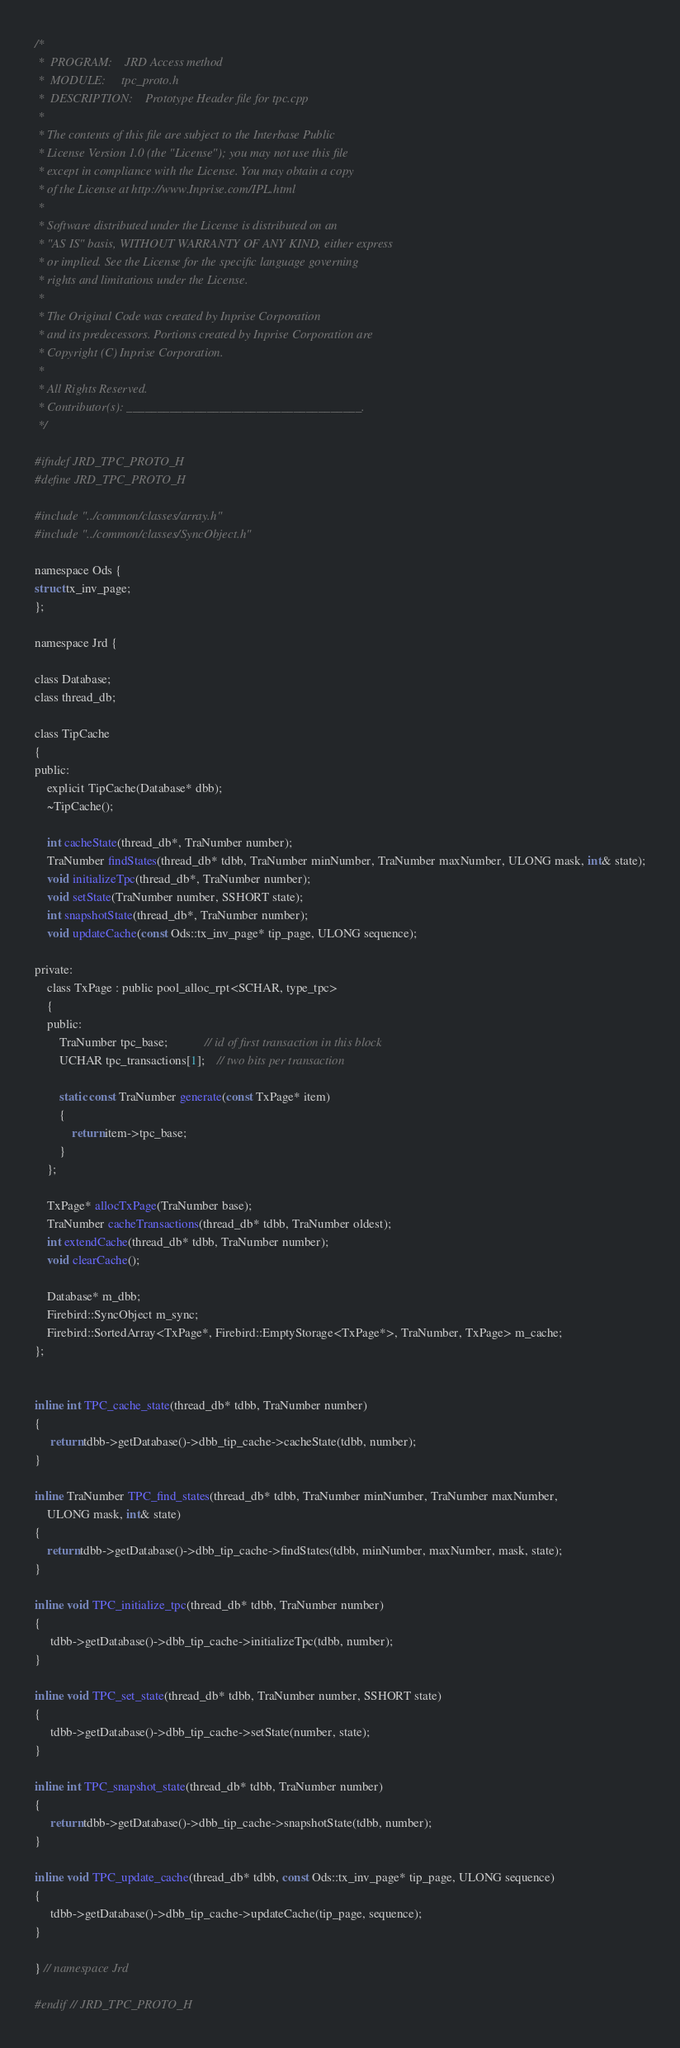<code> <loc_0><loc_0><loc_500><loc_500><_C_>/*
 *	PROGRAM:	JRD Access method
 *	MODULE:		tpc_proto.h
 *	DESCRIPTION:	Prototype Header file for tpc.cpp
 *
 * The contents of this file are subject to the Interbase Public
 * License Version 1.0 (the "License"); you may not use this file
 * except in compliance with the License. You may obtain a copy
 * of the License at http://www.Inprise.com/IPL.html
 *
 * Software distributed under the License is distributed on an
 * "AS IS" basis, WITHOUT WARRANTY OF ANY KIND, either express
 * or implied. See the License for the specific language governing
 * rights and limitations under the License.
 *
 * The Original Code was created by Inprise Corporation
 * and its predecessors. Portions created by Inprise Corporation are
 * Copyright (C) Inprise Corporation.
 *
 * All Rights Reserved.
 * Contributor(s): ______________________________________.
 */

#ifndef JRD_TPC_PROTO_H
#define JRD_TPC_PROTO_H

#include "../common/classes/array.h"
#include "../common/classes/SyncObject.h"

namespace Ods {
struct tx_inv_page;
};

namespace Jrd {

class Database;
class thread_db;

class TipCache
{
public:
	explicit TipCache(Database* dbb);
	~TipCache();

	int cacheState(thread_db*, TraNumber number);
	TraNumber findStates(thread_db* tdbb, TraNumber minNumber, TraNumber maxNumber, ULONG mask, int& state);
	void initializeTpc(thread_db*, TraNumber number);
	void setState(TraNumber number, SSHORT state);
	int snapshotState(thread_db*, TraNumber number);
	void updateCache(const Ods::tx_inv_page* tip_page, ULONG sequence);

private:
	class TxPage : public pool_alloc_rpt<SCHAR, type_tpc>
	{
	public:
		TraNumber tpc_base;			// id of first transaction in this block
		UCHAR tpc_transactions[1];	// two bits per transaction

		static const TraNumber generate(const TxPage* item)
		{
			return item->tpc_base;
		}
	};

	TxPage* allocTxPage(TraNumber base);
	TraNumber cacheTransactions(thread_db* tdbb, TraNumber oldest);
	int extendCache(thread_db* tdbb, TraNumber number);
	void clearCache();

	Database* m_dbb;
	Firebird::SyncObject m_sync;
	Firebird::SortedArray<TxPage*, Firebird::EmptyStorage<TxPage*>, TraNumber, TxPage> m_cache;
};


inline int TPC_cache_state(thread_db* tdbb, TraNumber number)
{
	 return tdbb->getDatabase()->dbb_tip_cache->cacheState(tdbb, number);
}

inline TraNumber TPC_find_states(thread_db* tdbb, TraNumber minNumber, TraNumber maxNumber,
	ULONG mask, int& state)
{
	return tdbb->getDatabase()->dbb_tip_cache->findStates(tdbb, minNumber, maxNumber, mask, state);
}

inline void TPC_initialize_tpc(thread_db* tdbb, TraNumber number)
{
	 tdbb->getDatabase()->dbb_tip_cache->initializeTpc(tdbb, number);
}

inline void TPC_set_state(thread_db* tdbb, TraNumber number, SSHORT state)
{
	 tdbb->getDatabase()->dbb_tip_cache->setState(number, state);
}

inline int TPC_snapshot_state(thread_db* tdbb, TraNumber number)
{
	 return tdbb->getDatabase()->dbb_tip_cache->snapshotState(tdbb, number);
}

inline void TPC_update_cache(thread_db* tdbb, const Ods::tx_inv_page* tip_page, ULONG sequence)
{
	 tdbb->getDatabase()->dbb_tip_cache->updateCache(tip_page, sequence);
}

} // namespace Jrd

#endif // JRD_TPC_PROTO_H
</code> 